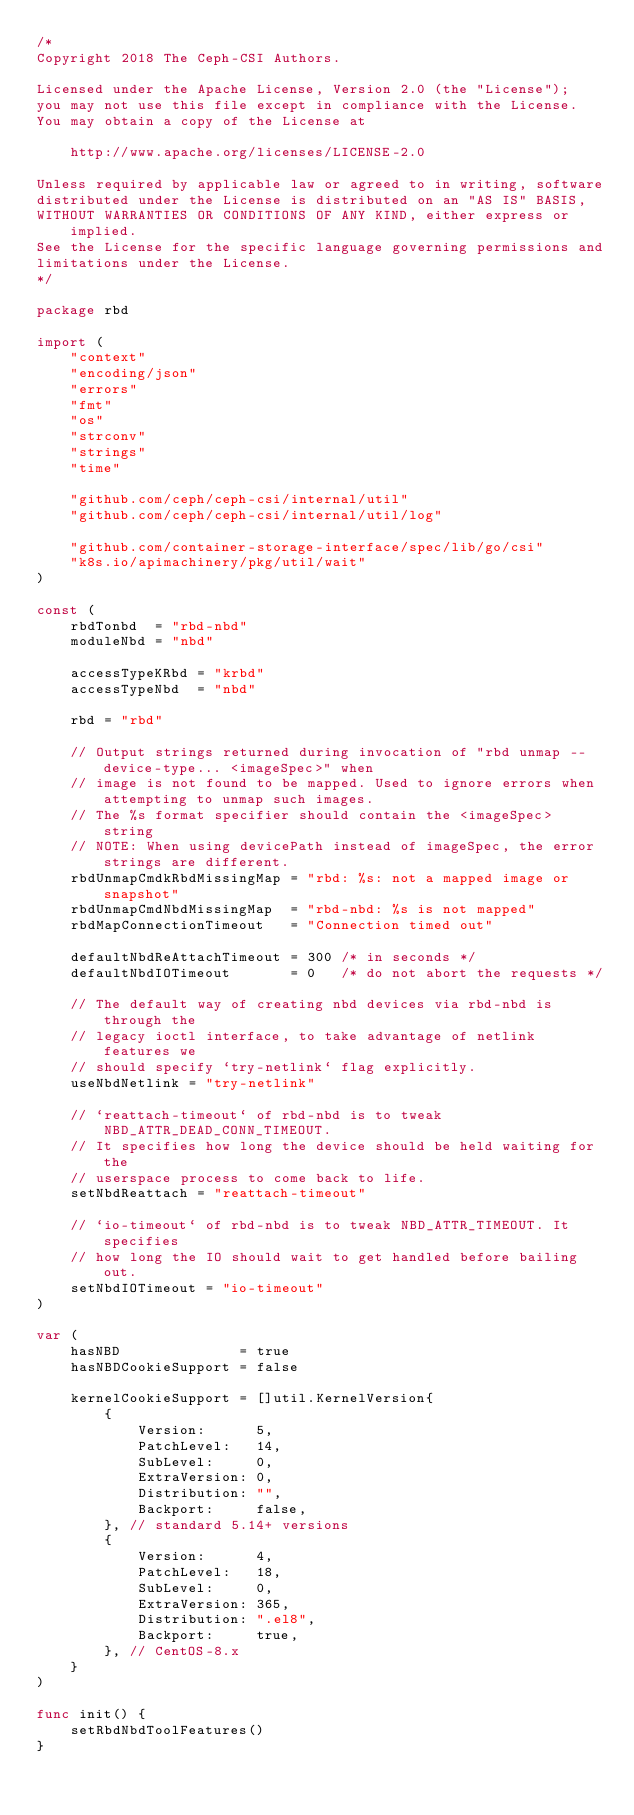Convert code to text. <code><loc_0><loc_0><loc_500><loc_500><_Go_>/*
Copyright 2018 The Ceph-CSI Authors.

Licensed under the Apache License, Version 2.0 (the "License");
you may not use this file except in compliance with the License.
You may obtain a copy of the License at

    http://www.apache.org/licenses/LICENSE-2.0

Unless required by applicable law or agreed to in writing, software
distributed under the License is distributed on an "AS IS" BASIS,
WITHOUT WARRANTIES OR CONDITIONS OF ANY KIND, either express or implied.
See the License for the specific language governing permissions and
limitations under the License.
*/

package rbd

import (
	"context"
	"encoding/json"
	"errors"
	"fmt"
	"os"
	"strconv"
	"strings"
	"time"

	"github.com/ceph/ceph-csi/internal/util"
	"github.com/ceph/ceph-csi/internal/util/log"

	"github.com/container-storage-interface/spec/lib/go/csi"
	"k8s.io/apimachinery/pkg/util/wait"
)

const (
	rbdTonbd  = "rbd-nbd"
	moduleNbd = "nbd"

	accessTypeKRbd = "krbd"
	accessTypeNbd  = "nbd"

	rbd = "rbd"

	// Output strings returned during invocation of "rbd unmap --device-type... <imageSpec>" when
	// image is not found to be mapped. Used to ignore errors when attempting to unmap such images.
	// The %s format specifier should contain the <imageSpec> string
	// NOTE: When using devicePath instead of imageSpec, the error strings are different.
	rbdUnmapCmdkRbdMissingMap = "rbd: %s: not a mapped image or snapshot"
	rbdUnmapCmdNbdMissingMap  = "rbd-nbd: %s is not mapped"
	rbdMapConnectionTimeout   = "Connection timed out"

	defaultNbdReAttachTimeout = 300 /* in seconds */
	defaultNbdIOTimeout       = 0   /* do not abort the requests */

	// The default way of creating nbd devices via rbd-nbd is through the
	// legacy ioctl interface, to take advantage of netlink features we
	// should specify `try-netlink` flag explicitly.
	useNbdNetlink = "try-netlink"

	// `reattach-timeout` of rbd-nbd is to tweak NBD_ATTR_DEAD_CONN_TIMEOUT.
	// It specifies how long the device should be held waiting for the
	// userspace process to come back to life.
	setNbdReattach = "reattach-timeout"

	// `io-timeout` of rbd-nbd is to tweak NBD_ATTR_TIMEOUT. It specifies
	// how long the IO should wait to get handled before bailing out.
	setNbdIOTimeout = "io-timeout"
)

var (
	hasNBD              = true
	hasNBDCookieSupport = false

	kernelCookieSupport = []util.KernelVersion{
		{
			Version:      5,
			PatchLevel:   14,
			SubLevel:     0,
			ExtraVersion: 0,
			Distribution: "",
			Backport:     false,
		}, // standard 5.14+ versions
		{
			Version:      4,
			PatchLevel:   18,
			SubLevel:     0,
			ExtraVersion: 365,
			Distribution: ".el8",
			Backport:     true,
		}, // CentOS-8.x
	}
)

func init() {
	setRbdNbdToolFeatures()
}
</code> 